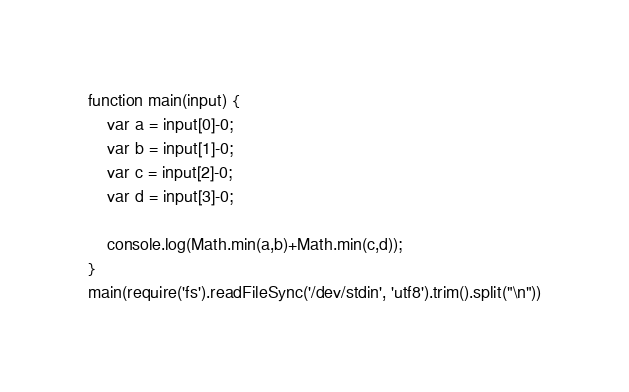<code> <loc_0><loc_0><loc_500><loc_500><_JavaScript_>function main(input) {
    var a = input[0]-0;
    var b = input[1]-0;
    var c = input[2]-0;
    var d = input[3]-0;
    
    console.log(Math.min(a,b)+Math.min(c,d));
}
main(require('fs').readFileSync('/dev/stdin', 'utf8').trim().split("\n"))
</code> 